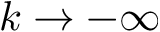Convert formula to latex. <formula><loc_0><loc_0><loc_500><loc_500>k \rightarrow - \infty</formula> 